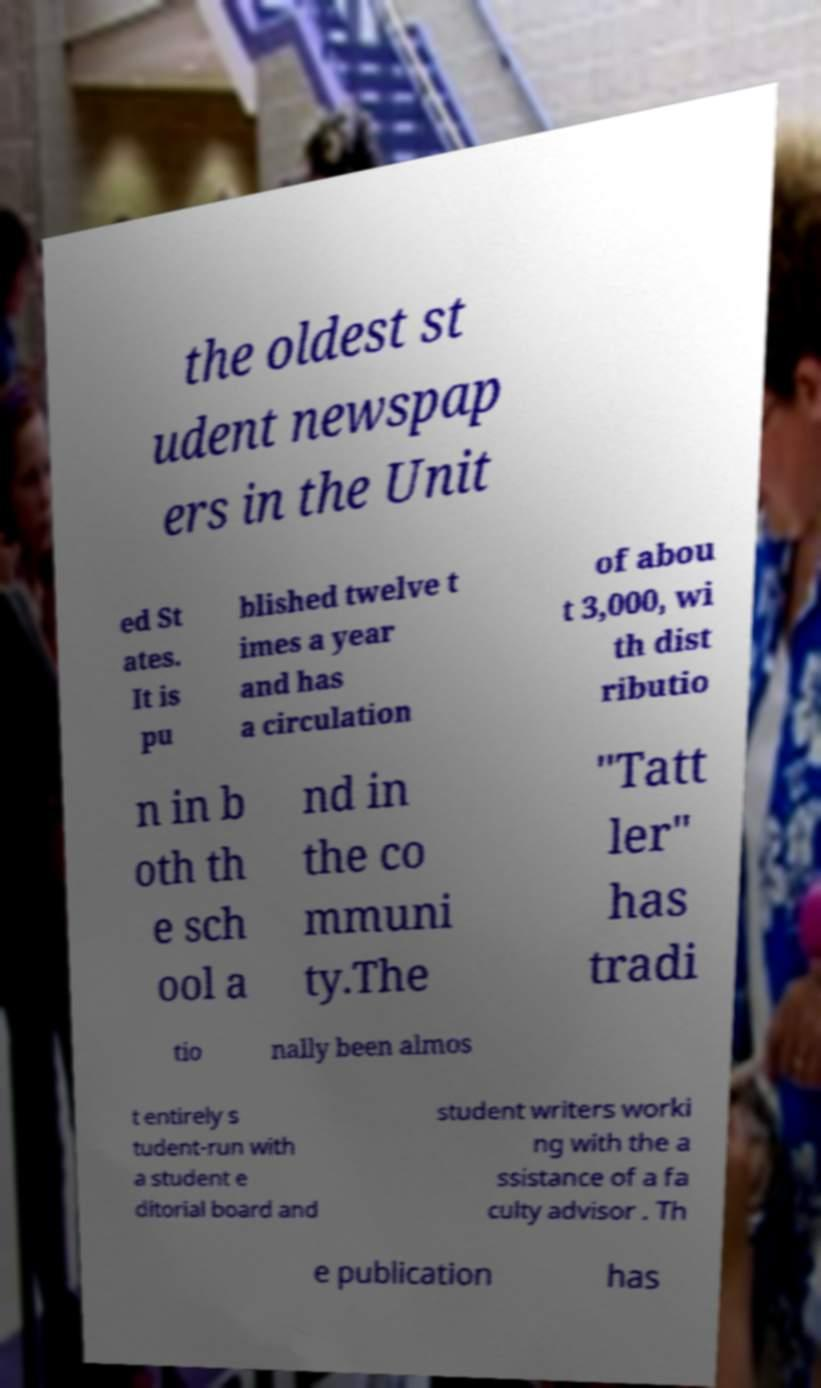Please read and relay the text visible in this image. What does it say? the oldest st udent newspap ers in the Unit ed St ates. It is pu blished twelve t imes a year and has a circulation of abou t 3,000, wi th dist ributio n in b oth th e sch ool a nd in the co mmuni ty.The "Tatt ler" has tradi tio nally been almos t entirely s tudent-run with a student e ditorial board and student writers worki ng with the a ssistance of a fa culty advisor . Th e publication has 